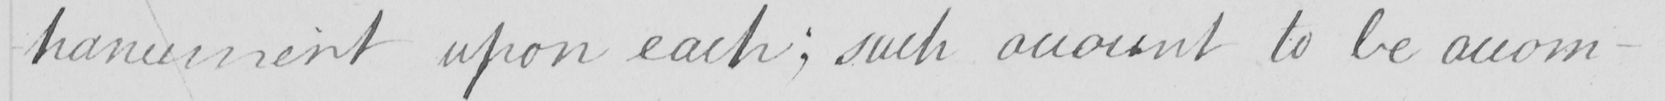What is written in this line of handwriting? -hancement upon each  ; such account to be accom- 